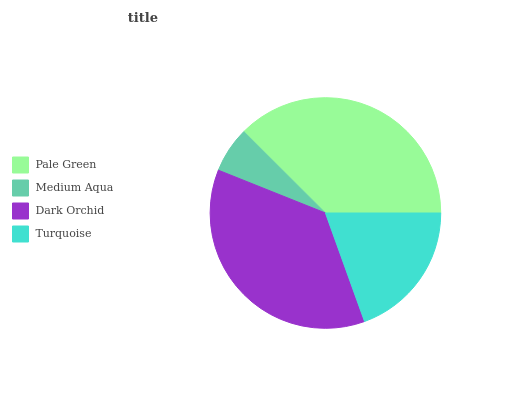Is Medium Aqua the minimum?
Answer yes or no. Yes. Is Pale Green the maximum?
Answer yes or no. Yes. Is Dark Orchid the minimum?
Answer yes or no. No. Is Dark Orchid the maximum?
Answer yes or no. No. Is Dark Orchid greater than Medium Aqua?
Answer yes or no. Yes. Is Medium Aqua less than Dark Orchid?
Answer yes or no. Yes. Is Medium Aqua greater than Dark Orchid?
Answer yes or no. No. Is Dark Orchid less than Medium Aqua?
Answer yes or no. No. Is Dark Orchid the high median?
Answer yes or no. Yes. Is Turquoise the low median?
Answer yes or no. Yes. Is Pale Green the high median?
Answer yes or no. No. Is Dark Orchid the low median?
Answer yes or no. No. 